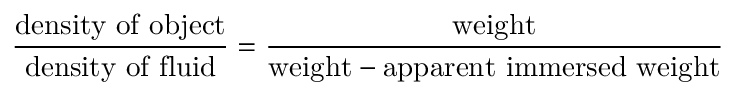<formula> <loc_0><loc_0><loc_500><loc_500>{ \frac { d e n s i t y o f o b j e c t } { d e n s i t y o f f l u i d } } = { \frac { w e i g h t } { { w e i g h t } - { a p p a r e n t i m m e r s e d w e i g h t } } }</formula> 